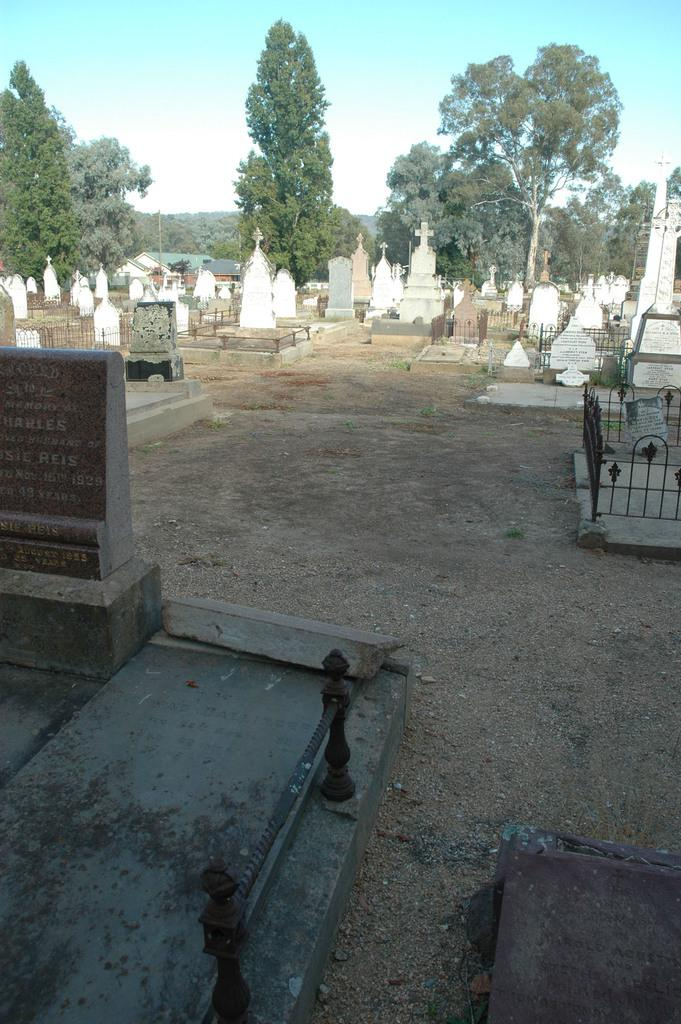What type of location is depicted in the image? There is a graveyard in the image. What objects are present in the graveyard? There are metal barricades and a cross in the image. What can be seen in the background of the image? There is a group of trees and the sky visible in the background of the image. How many sheep are grazing in the graveyard in the image? There are no sheep present in the image; it depicts a graveyard with metal barricades, a cross, and a background of trees and sky. 